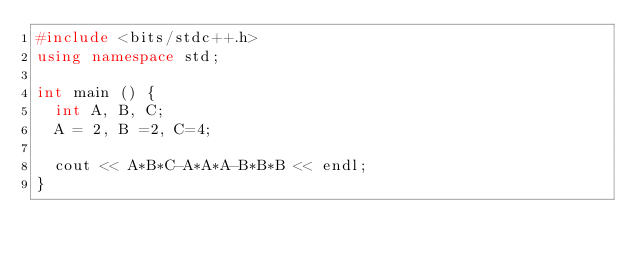Convert code to text. <code><loc_0><loc_0><loc_500><loc_500><_C++_>#include <bits/stdc++.h>
using namespace std;

int main () {
  int A, B, C;
  A = 2, B =2, C=4;
  
  cout << A*B*C-A*A*A-B*B*B << endl;
}</code> 